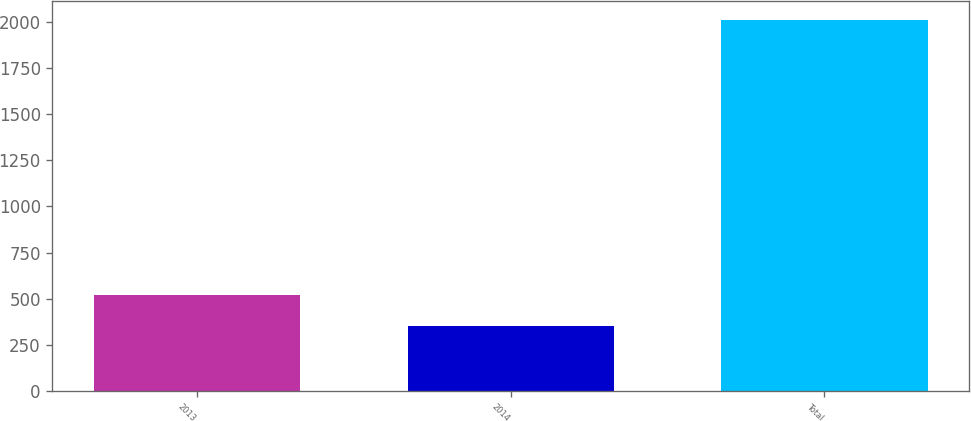Convert chart to OTSL. <chart><loc_0><loc_0><loc_500><loc_500><bar_chart><fcel>2013<fcel>2014<fcel>Total<nl><fcel>519.2<fcel>353<fcel>2015<nl></chart> 